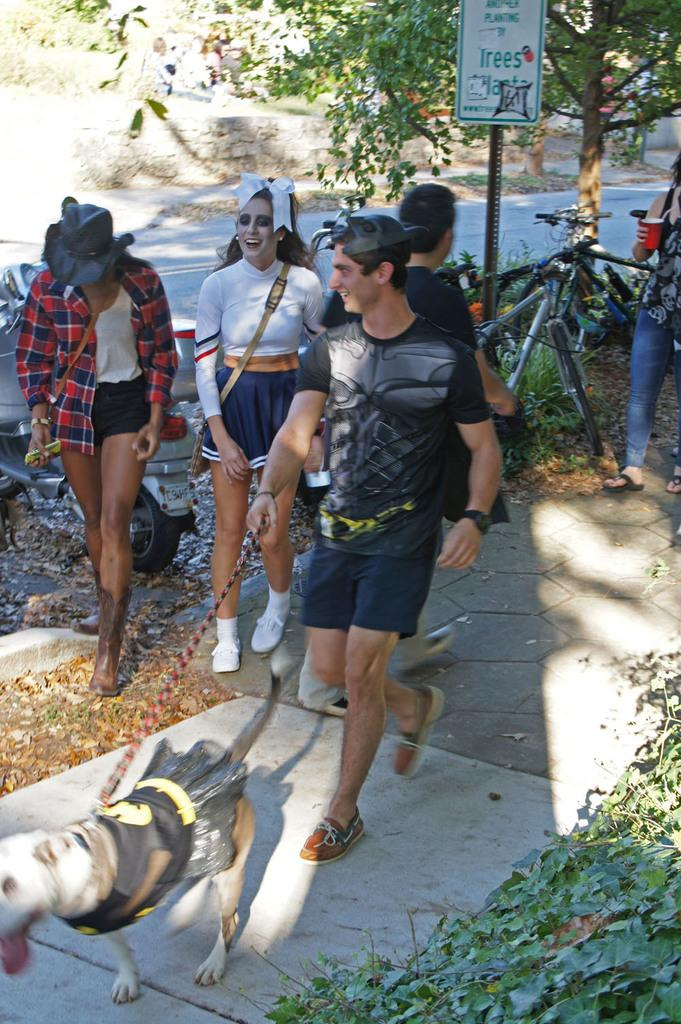What are the people in the image doing? The people in the image are walking on the road. Is there any interaction between a person and an animal in the image? Yes, one person is holding a dog. What mode of transportation can be seen in the image? There is a bicycle in the image. What type of natural feature is visible in the image? Trees and a hill are visible in the image. What type of brush is being used to paint the hill in the image? There is no brush or painting activity present in the image; it is a photograph of people walking, a dog, a bicycle, trees, and a hill. 